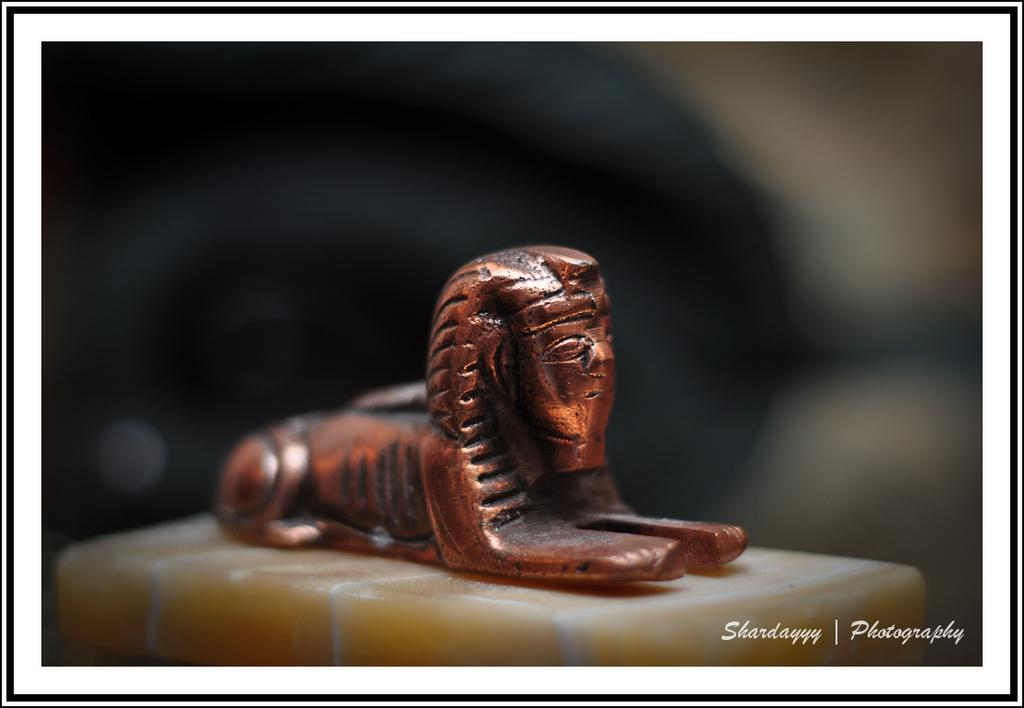What is the main subject in the image? There is a statue on the surface in the image. Can you describe the background of the image? The background of the image is blurred. Is there any additional information or markings on the image? Yes, there is a watermark on the right side, bottom of the image. What type of appliance is being used to apply oil to the statue in the image? There is no appliance or oil present in the image; it only features a statue and a blurred background. 